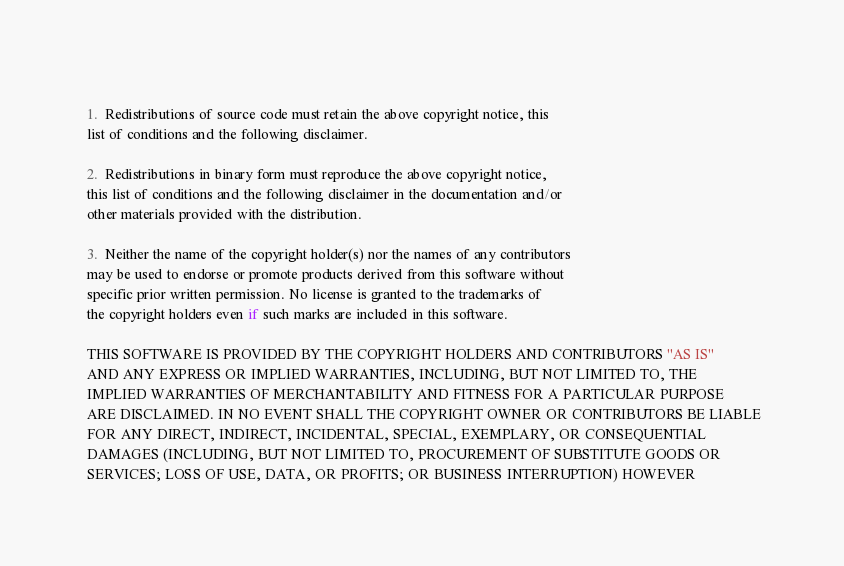<code> <loc_0><loc_0><loc_500><loc_500><_C_> 
 1.  Redistributions of source code must retain the above copyright notice, this
 list of conditions and the following disclaimer.
 
 2.  Redistributions in binary form must reproduce the above copyright notice,
 this list of conditions and the following disclaimer in the documentation and/or
 other materials provided with the distribution.
 
 3.  Neither the name of the copyright holder(s) nor the names of any contributors
 may be used to endorse or promote products derived from this software without
 specific prior written permission. No license is granted to the trademarks of
 the copyright holders even if such marks are included in this software.
 
 THIS SOFTWARE IS PROVIDED BY THE COPYRIGHT HOLDERS AND CONTRIBUTORS "AS IS"
 AND ANY EXPRESS OR IMPLIED WARRANTIES, INCLUDING, BUT NOT LIMITED TO, THE
 IMPLIED WARRANTIES OF MERCHANTABILITY AND FITNESS FOR A PARTICULAR PURPOSE
 ARE DISCLAIMED. IN NO EVENT SHALL THE COPYRIGHT OWNER OR CONTRIBUTORS BE LIABLE
 FOR ANY DIRECT, INDIRECT, INCIDENTAL, SPECIAL, EXEMPLARY, OR CONSEQUENTIAL
 DAMAGES (INCLUDING, BUT NOT LIMITED TO, PROCUREMENT OF SUBSTITUTE GOODS OR
 SERVICES; LOSS OF USE, DATA, OR PROFITS; OR BUSINESS INTERRUPTION) HOWEVER</code> 